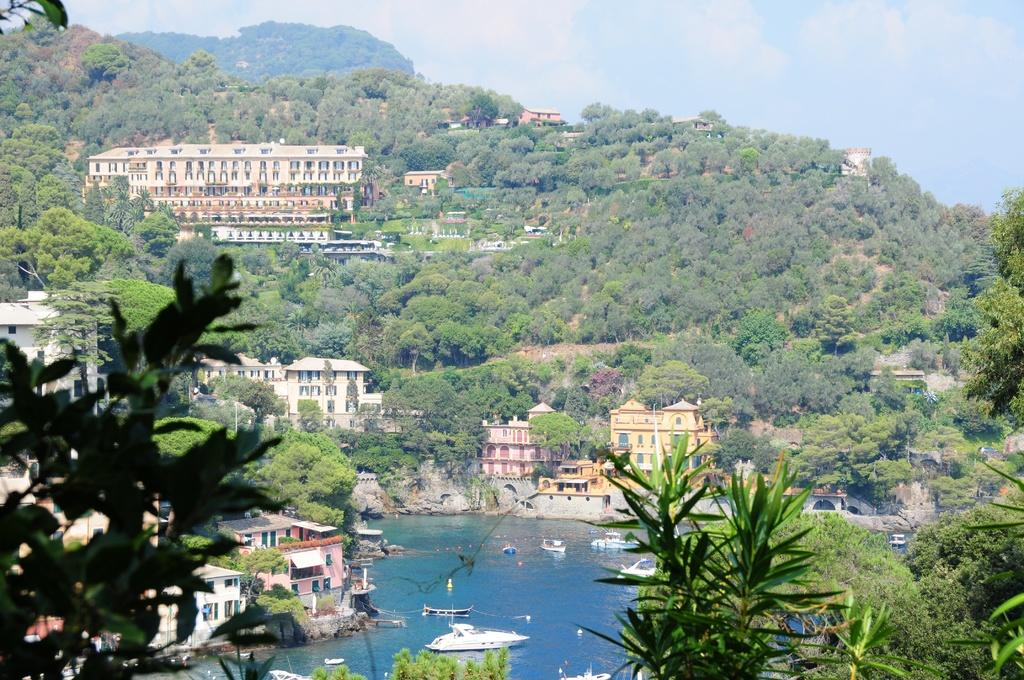What type of natural landscape is depicted in the image? The image contains forest mountains. What type of man-made structures are present in the image? There are many buildings in the image. What body of water is visible in the image? There is a sea visible in the image. What type of vehicles can be seen on the sea? There are water crafts moving on the sea in the image. What type of medical treatment is being administered in the image? There is no medical treatment being administered in the image; it features forest mountains, buildings, a sea, and water crafts. 